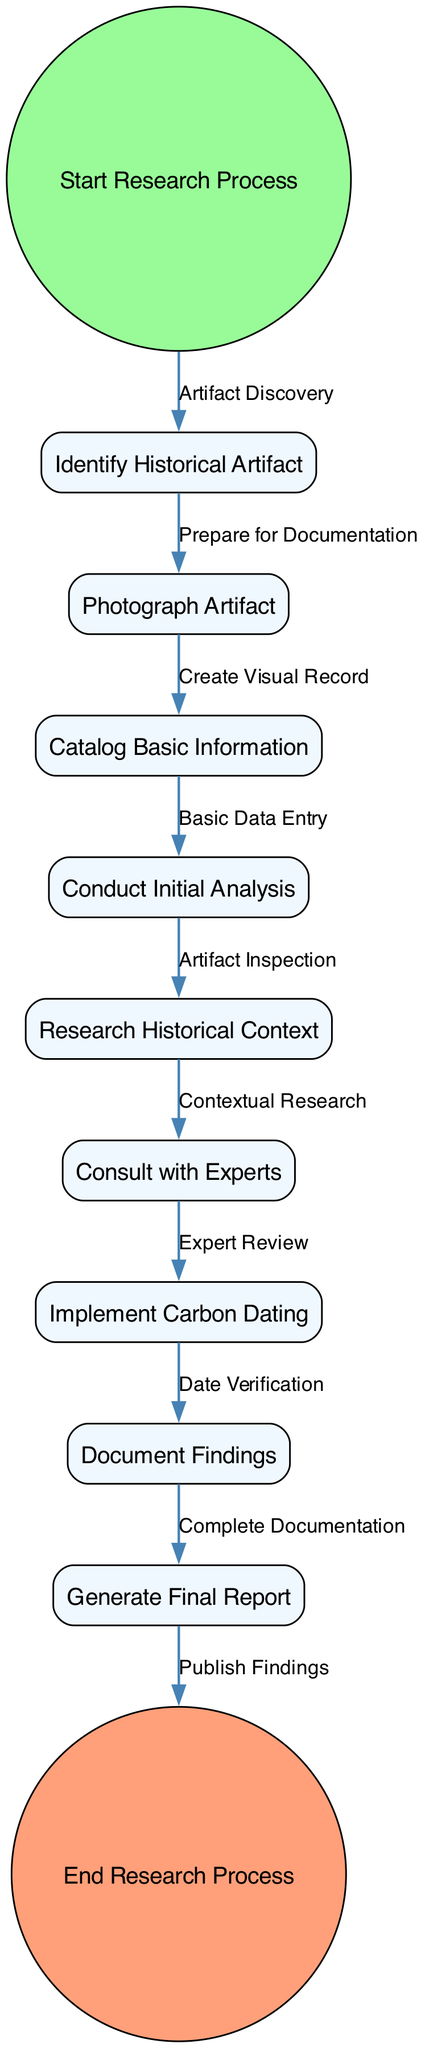What is the first activity in the research process? The first activity is labeled "Start Research Process," which is shown as the starting point in the diagram.
Answer: Start Research Process How many nodes are present in the diagram? By counting each unique activity represented in the diagram, we find a total of 11 nodes including the start and end nodes.
Answer: 11 What is the last activity that occurs before the end of the research process? The last activity before reaching the "End Research Process" node is "Generate Final Report," which directly transitions to the end.
Answer: Generate Final Report Which activity involves consulting experts? The activity "Consult with Experts" is the one where experts are consulted, indicated by its specific label in the diagram.
Answer: Consult with Experts What activity follows "Conduct Initial Analysis"? The subsequent activity to "Conduct Initial Analysis" is "Research Historical Context," as indicated by the direct transition from one to the other.
Answer: Research Historical Context What transition leads to the documentation of findings? The transition labeled "Complete Documentation," which follows "Document Findings," leads to the generation of a final report.
Answer: Complete Documentation How many transitions are present in the diagram? Counting the connecting edges that show the flow from one activity to another, there are 10 transitions in total.
Answer: 10 Which two activities are connected by the transition labeled "Date Verification"? The activities "Implement Carbon Dating" and "Document Findings" are connected by the transition titled "Date Verification," indicating the flow between these two steps.
Answer: Implement Carbon Dating, Document Findings What is the initial action taken to start the research process? The initial action is "Artifact Discovery," which is represented as the transition from the start node to the next activity node.
Answer: Artifact Discovery 